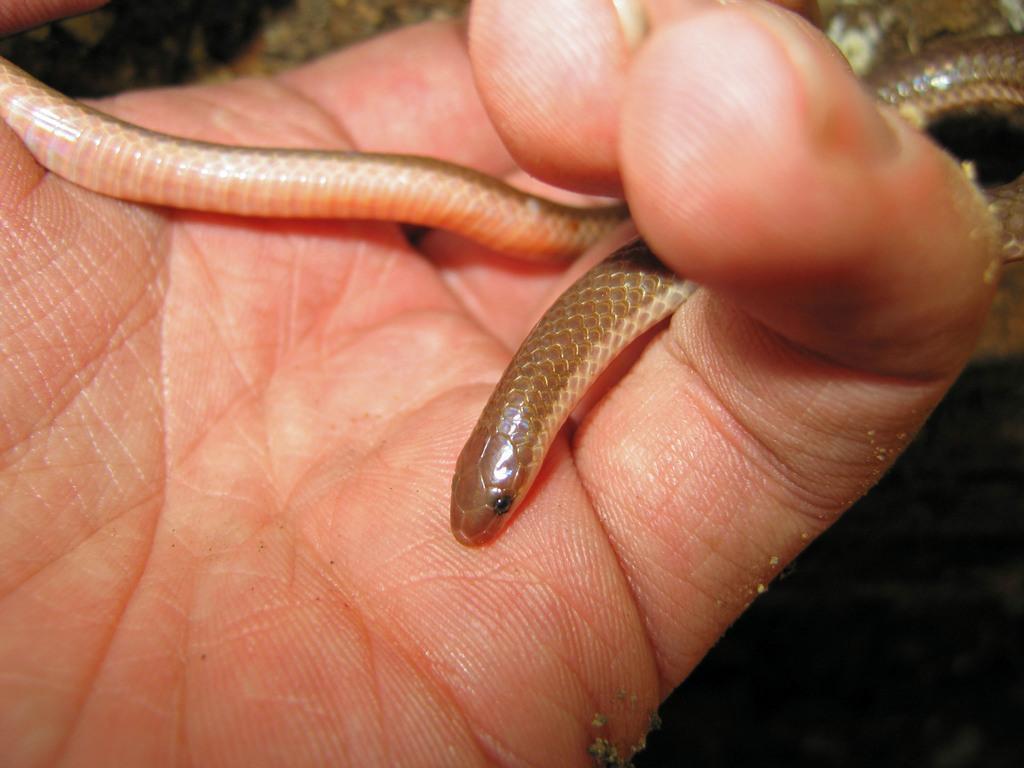Please provide a concise description of this image. In this image, we can see the hand of a person with a snake. The background of the image is dark. 